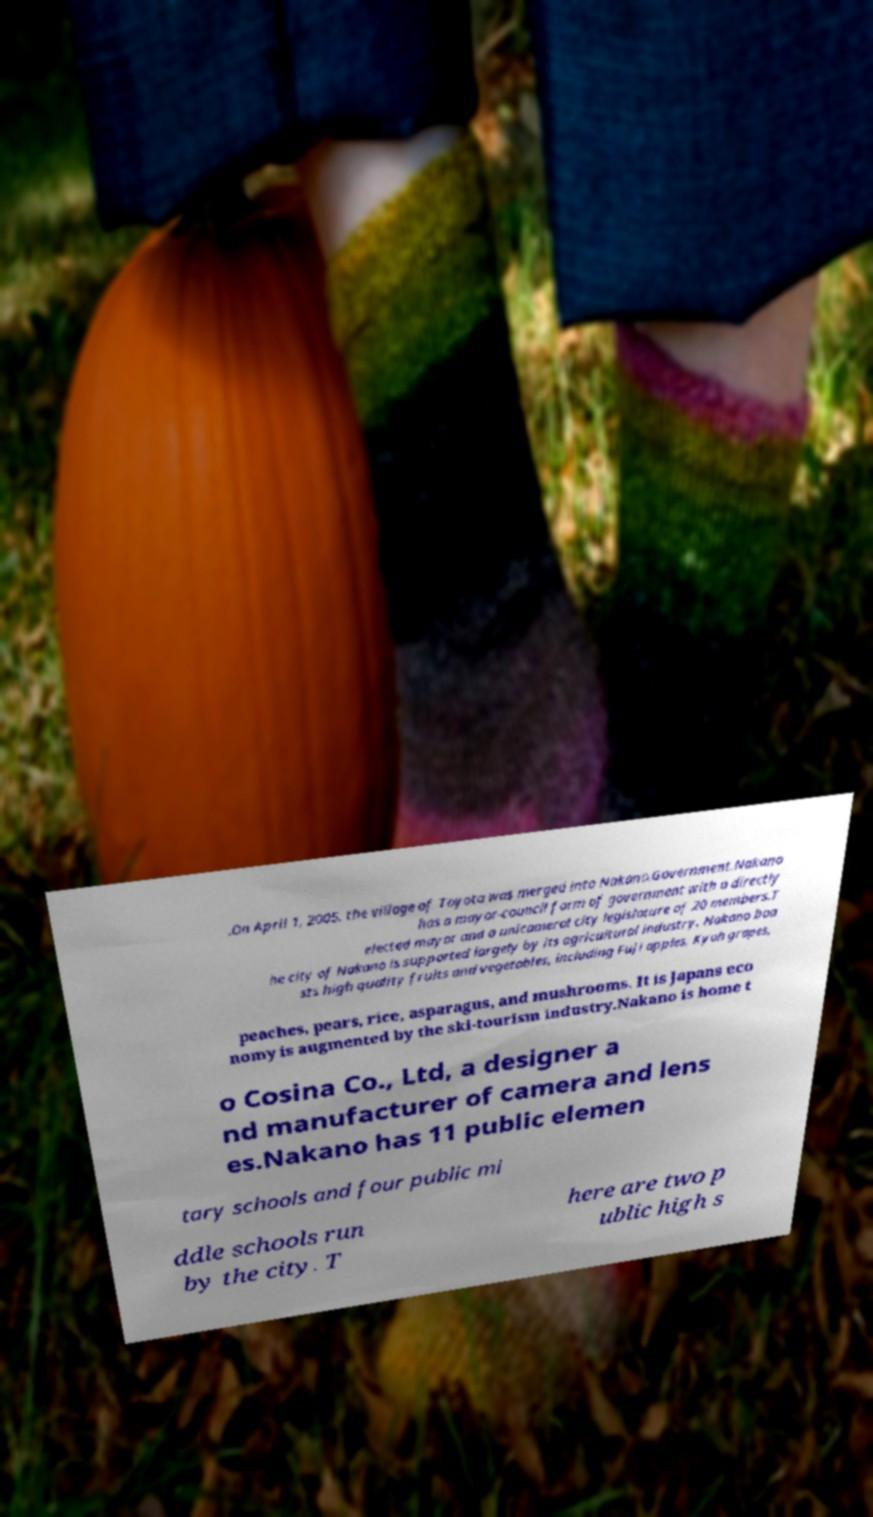There's text embedded in this image that I need extracted. Can you transcribe it verbatim? .On April 1, 2005, the village of Toyota was merged into Nakano.Government.Nakano has a mayor-council form of government with a directly elected mayor and a unicameral city legislature of 20 members.T he city of Nakano is supported largely by its agricultural industry. Nakano boa sts high quality fruits and vegetables, including Fuji apples, Kyoh grapes, peaches, pears, rice, asparagus, and mushrooms. It is Japans eco nomy is augmented by the ski-tourism industry.Nakano is home t o Cosina Co., Ltd, a designer a nd manufacturer of camera and lens es.Nakano has 11 public elemen tary schools and four public mi ddle schools run by the city. T here are two p ublic high s 